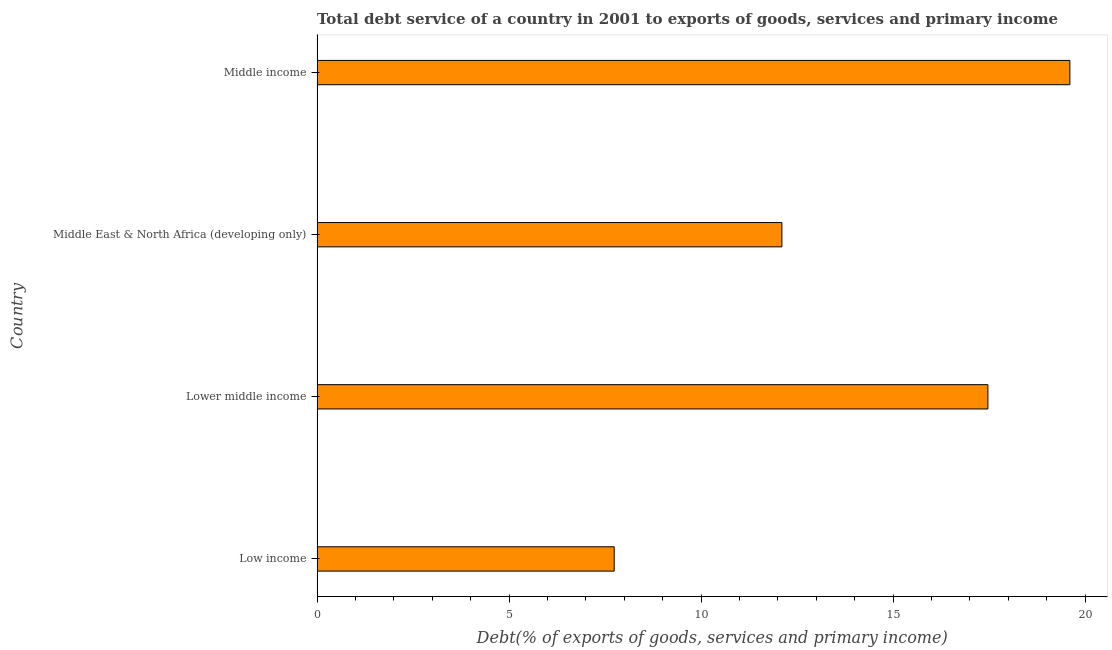What is the title of the graph?
Give a very brief answer. Total debt service of a country in 2001 to exports of goods, services and primary income. What is the label or title of the X-axis?
Your response must be concise. Debt(% of exports of goods, services and primary income). What is the total debt service in Middle East & North Africa (developing only)?
Offer a very short reply. 12.1. Across all countries, what is the maximum total debt service?
Provide a short and direct response. 19.6. Across all countries, what is the minimum total debt service?
Your answer should be compact. 7.74. In which country was the total debt service minimum?
Provide a short and direct response. Low income. What is the sum of the total debt service?
Your answer should be very brief. 56.91. What is the difference between the total debt service in Low income and Lower middle income?
Your answer should be very brief. -9.73. What is the average total debt service per country?
Ensure brevity in your answer.  14.23. What is the median total debt service?
Your answer should be very brief. 14.79. What is the ratio of the total debt service in Lower middle income to that in Middle East & North Africa (developing only)?
Give a very brief answer. 1.44. Is the difference between the total debt service in Lower middle income and Middle East & North Africa (developing only) greater than the difference between any two countries?
Offer a terse response. No. What is the difference between the highest and the second highest total debt service?
Your answer should be compact. 2.13. Is the sum of the total debt service in Middle East & North Africa (developing only) and Middle income greater than the maximum total debt service across all countries?
Keep it short and to the point. Yes. What is the difference between the highest and the lowest total debt service?
Offer a very short reply. 11.86. How many bars are there?
Your answer should be compact. 4. Are all the bars in the graph horizontal?
Provide a succinct answer. Yes. Are the values on the major ticks of X-axis written in scientific E-notation?
Your response must be concise. No. What is the Debt(% of exports of goods, services and primary income) in Low income?
Provide a short and direct response. 7.74. What is the Debt(% of exports of goods, services and primary income) of Lower middle income?
Provide a short and direct response. 17.47. What is the Debt(% of exports of goods, services and primary income) in Middle East & North Africa (developing only)?
Your response must be concise. 12.1. What is the Debt(% of exports of goods, services and primary income) in Middle income?
Provide a short and direct response. 19.6. What is the difference between the Debt(% of exports of goods, services and primary income) in Low income and Lower middle income?
Provide a short and direct response. -9.73. What is the difference between the Debt(% of exports of goods, services and primary income) in Low income and Middle East & North Africa (developing only)?
Give a very brief answer. -4.37. What is the difference between the Debt(% of exports of goods, services and primary income) in Low income and Middle income?
Your answer should be compact. -11.86. What is the difference between the Debt(% of exports of goods, services and primary income) in Lower middle income and Middle East & North Africa (developing only)?
Offer a very short reply. 5.36. What is the difference between the Debt(% of exports of goods, services and primary income) in Lower middle income and Middle income?
Give a very brief answer. -2.13. What is the difference between the Debt(% of exports of goods, services and primary income) in Middle East & North Africa (developing only) and Middle income?
Your response must be concise. -7.5. What is the ratio of the Debt(% of exports of goods, services and primary income) in Low income to that in Lower middle income?
Give a very brief answer. 0.44. What is the ratio of the Debt(% of exports of goods, services and primary income) in Low income to that in Middle East & North Africa (developing only)?
Ensure brevity in your answer.  0.64. What is the ratio of the Debt(% of exports of goods, services and primary income) in Low income to that in Middle income?
Provide a short and direct response. 0.4. What is the ratio of the Debt(% of exports of goods, services and primary income) in Lower middle income to that in Middle East & North Africa (developing only)?
Ensure brevity in your answer.  1.44. What is the ratio of the Debt(% of exports of goods, services and primary income) in Lower middle income to that in Middle income?
Keep it short and to the point. 0.89. What is the ratio of the Debt(% of exports of goods, services and primary income) in Middle East & North Africa (developing only) to that in Middle income?
Make the answer very short. 0.62. 